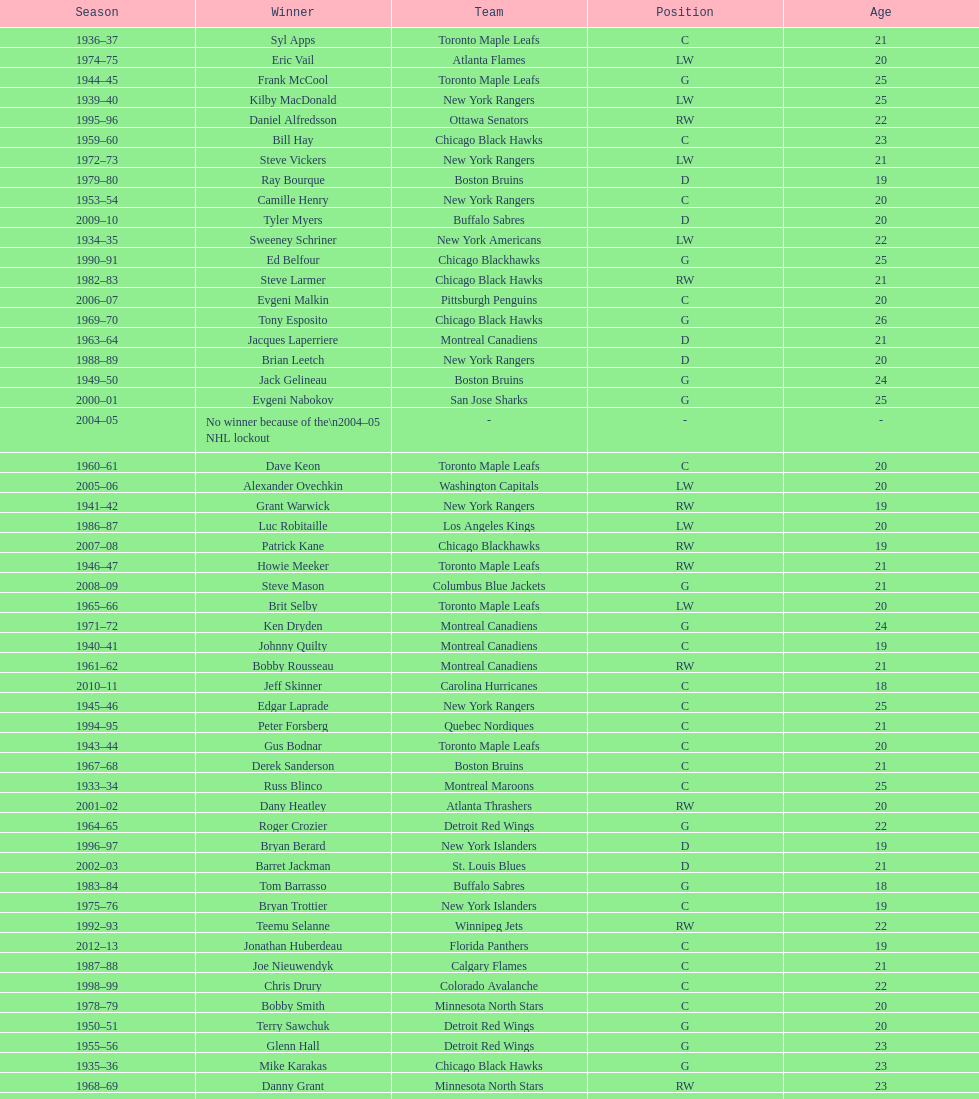Who was the first calder memorial trophy winner from the boston bruins? Frank Brimsek. 